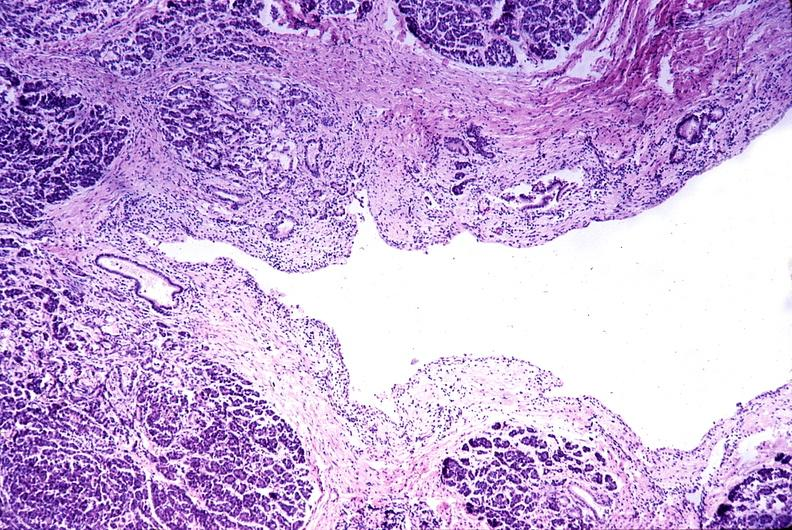does this image show chronic pancreatitis?
Answer the question using a single word or phrase. Yes 